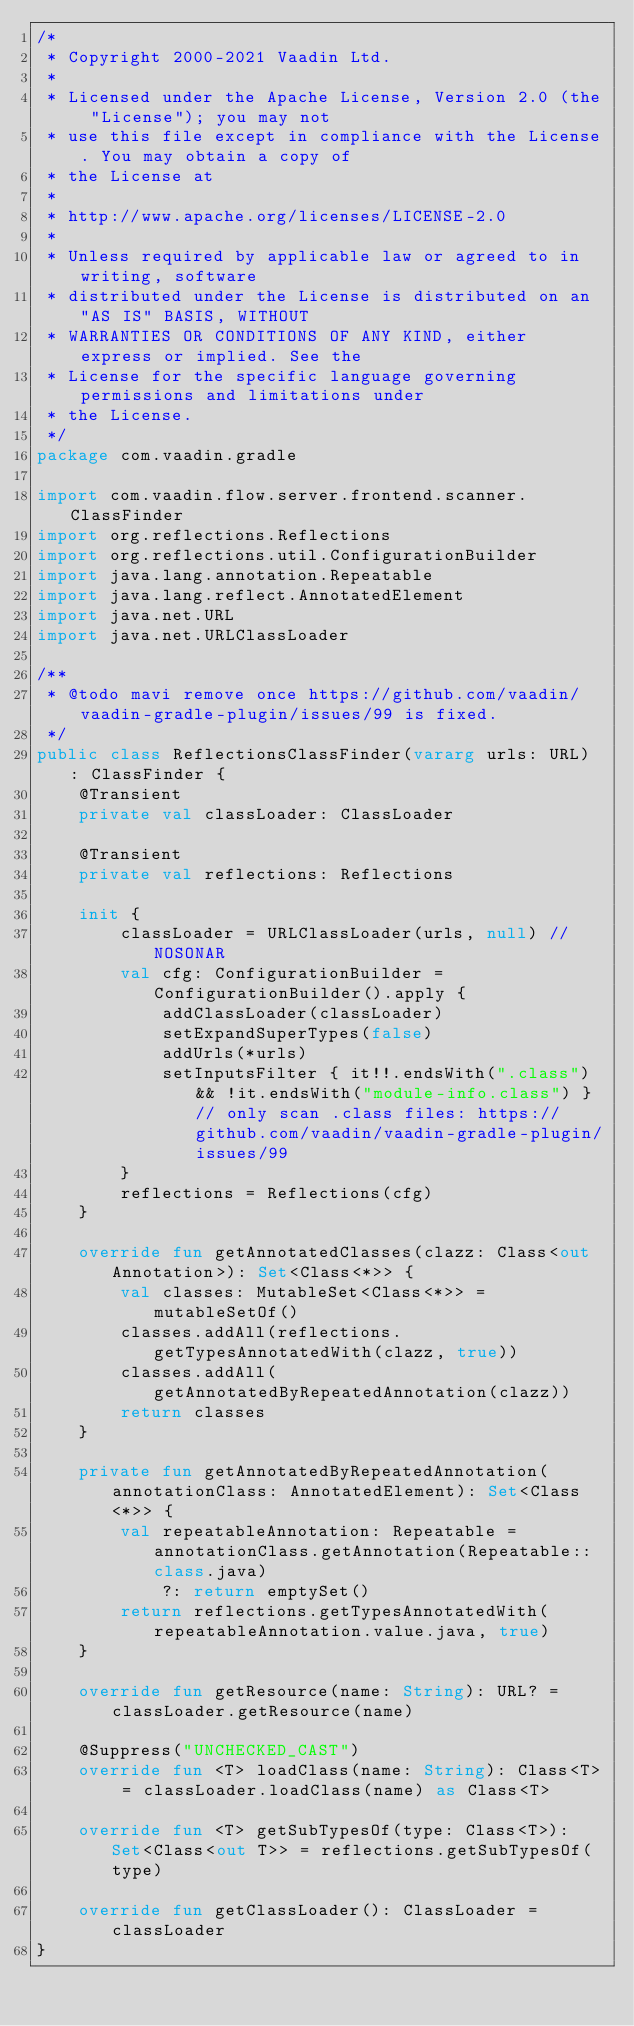Convert code to text. <code><loc_0><loc_0><loc_500><loc_500><_Kotlin_>/*
 * Copyright 2000-2021 Vaadin Ltd.
 *
 * Licensed under the Apache License, Version 2.0 (the "License"); you may not
 * use this file except in compliance with the License. You may obtain a copy of
 * the License at
 *
 * http://www.apache.org/licenses/LICENSE-2.0
 *
 * Unless required by applicable law or agreed to in writing, software
 * distributed under the License is distributed on an "AS IS" BASIS, WITHOUT
 * WARRANTIES OR CONDITIONS OF ANY KIND, either express or implied. See the
 * License for the specific language governing permissions and limitations under
 * the License.
 */
package com.vaadin.gradle

import com.vaadin.flow.server.frontend.scanner.ClassFinder
import org.reflections.Reflections
import org.reflections.util.ConfigurationBuilder
import java.lang.annotation.Repeatable
import java.lang.reflect.AnnotatedElement
import java.net.URL
import java.net.URLClassLoader

/**
 * @todo mavi remove once https://github.com/vaadin/vaadin-gradle-plugin/issues/99 is fixed.
 */
public class ReflectionsClassFinder(vararg urls: URL) : ClassFinder {
    @Transient
    private val classLoader: ClassLoader

    @Transient
    private val reflections: Reflections

    init {
        classLoader = URLClassLoader(urls, null) // NOSONAR
        val cfg: ConfigurationBuilder = ConfigurationBuilder().apply {
            addClassLoader(classLoader)
            setExpandSuperTypes(false)
            addUrls(*urls)
            setInputsFilter { it!!.endsWith(".class") && !it.endsWith("module-info.class") } // only scan .class files: https://github.com/vaadin/vaadin-gradle-plugin/issues/99
        }
        reflections = Reflections(cfg)
    }

    override fun getAnnotatedClasses(clazz: Class<out Annotation>): Set<Class<*>> {
        val classes: MutableSet<Class<*>> = mutableSetOf()
        classes.addAll(reflections.getTypesAnnotatedWith(clazz, true))
        classes.addAll(getAnnotatedByRepeatedAnnotation(clazz))
        return classes
    }

    private fun getAnnotatedByRepeatedAnnotation(annotationClass: AnnotatedElement): Set<Class<*>> {
        val repeatableAnnotation: Repeatable = annotationClass.getAnnotation(Repeatable::class.java)
            ?: return emptySet()
        return reflections.getTypesAnnotatedWith(repeatableAnnotation.value.java, true)
    }

    override fun getResource(name: String): URL? = classLoader.getResource(name)

    @Suppress("UNCHECKED_CAST")
    override fun <T> loadClass(name: String): Class<T> = classLoader.loadClass(name) as Class<T>

    override fun <T> getSubTypesOf(type: Class<T>): Set<Class<out T>> = reflections.getSubTypesOf(type)

    override fun getClassLoader(): ClassLoader = classLoader
}
</code> 